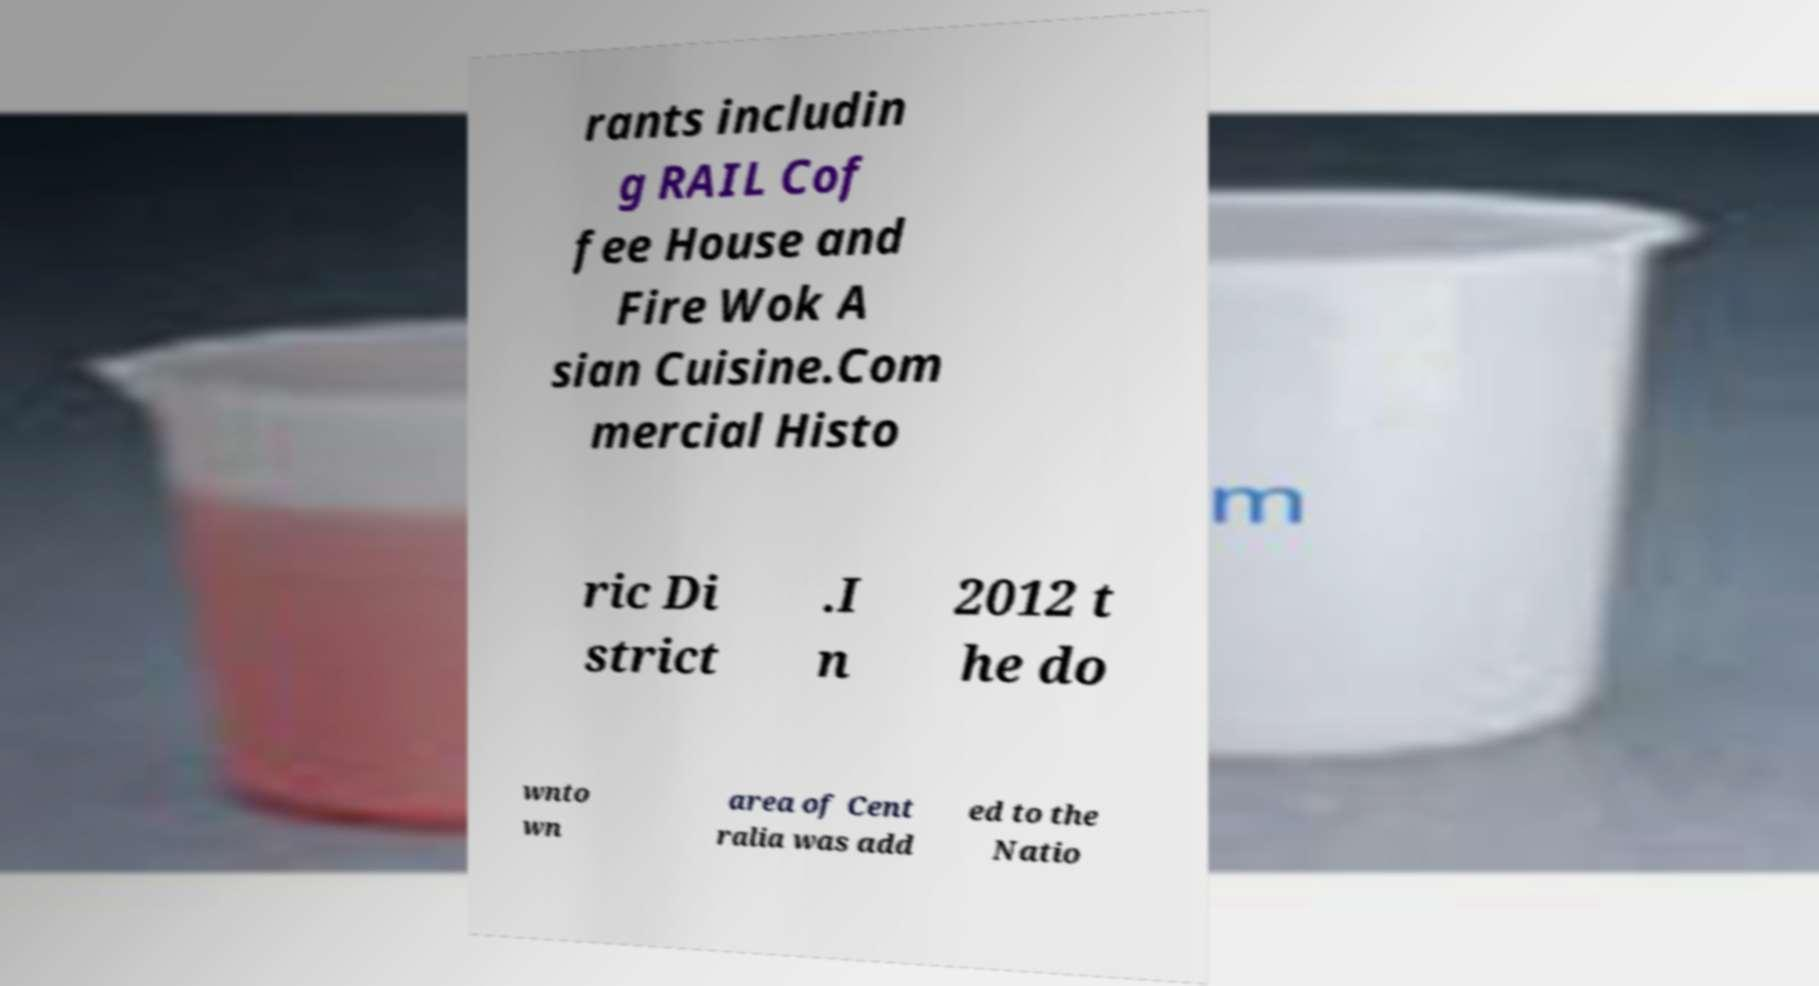There's text embedded in this image that I need extracted. Can you transcribe it verbatim? rants includin g RAIL Cof fee House and Fire Wok A sian Cuisine.Com mercial Histo ric Di strict .I n 2012 t he do wnto wn area of Cent ralia was add ed to the Natio 